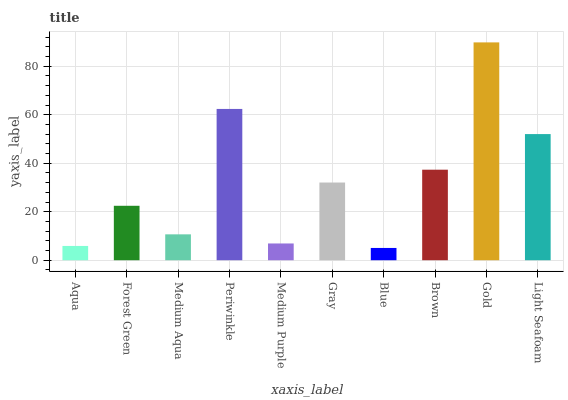Is Blue the minimum?
Answer yes or no. Yes. Is Gold the maximum?
Answer yes or no. Yes. Is Forest Green the minimum?
Answer yes or no. No. Is Forest Green the maximum?
Answer yes or no. No. Is Forest Green greater than Aqua?
Answer yes or no. Yes. Is Aqua less than Forest Green?
Answer yes or no. Yes. Is Aqua greater than Forest Green?
Answer yes or no. No. Is Forest Green less than Aqua?
Answer yes or no. No. Is Gray the high median?
Answer yes or no. Yes. Is Forest Green the low median?
Answer yes or no. Yes. Is Forest Green the high median?
Answer yes or no. No. Is Brown the low median?
Answer yes or no. No. 